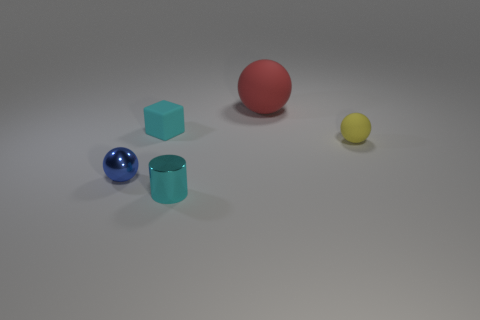What size is the cyan object behind the metal thing that is behind the cyan object in front of the tiny cyan block?
Offer a terse response. Small. What is the material of the yellow thing that is the same shape as the big red object?
Provide a succinct answer. Rubber. Is there anything else that has the same size as the block?
Your answer should be compact. Yes. There is a metal thing in front of the blue object on the left side of the cyan shiny cylinder; what is its size?
Make the answer very short. Small. The metallic sphere has what color?
Your answer should be very brief. Blue. What number of tiny yellow rubber spheres are left of the matte sphere in front of the red ball?
Give a very brief answer. 0. Are there any big red rubber balls in front of the thing right of the red sphere?
Your answer should be compact. No. Are there any yellow things to the left of the big red matte thing?
Ensure brevity in your answer.  No. Is the shape of the tiny rubber thing that is behind the yellow matte sphere the same as  the yellow thing?
Ensure brevity in your answer.  No. What number of other tiny objects are the same shape as the blue object?
Make the answer very short. 1. 